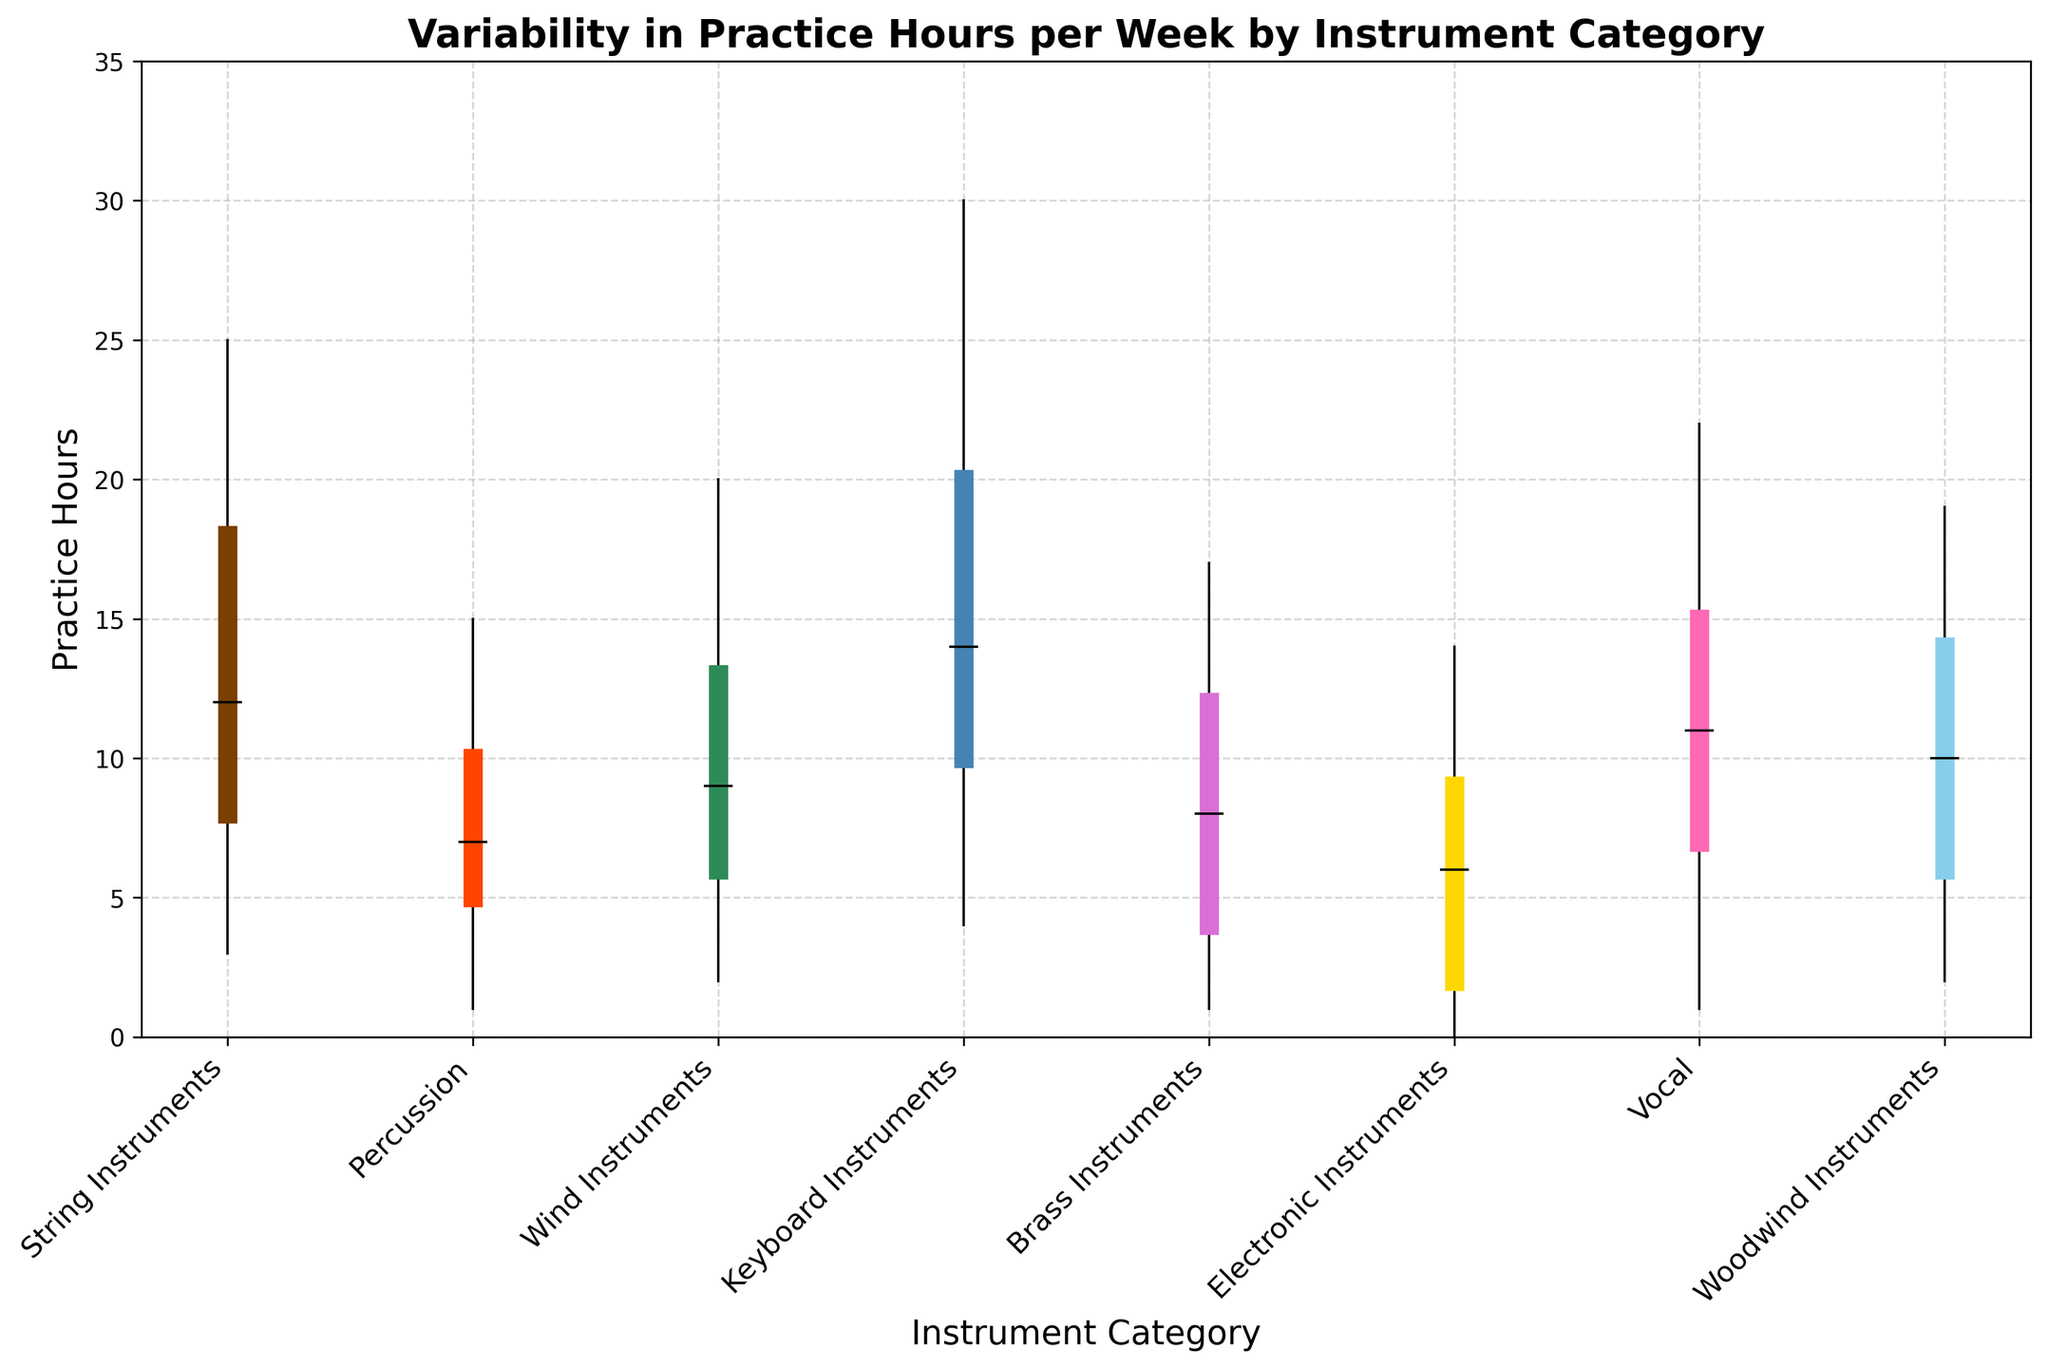Which instrument category has the highest median practice hours? The highest median practice hours can be found by comparing the median values for each instrument category. Keyboard Instruments have a median of 14 hours, which is the highest.
Answer: Keyboard Instruments Which instrument category has the lowest minimum practice hours? The lowest minimum practice hours can be determined by comparing the minimum values for each instrument category. Electronic Instruments have a minimum of 0 hours, which is the lowest.
Answer: Electronic Instruments How many more practice hours do the third quartile for String Instruments have compared to the median of Wind Instruments? The third quartile for String Instruments is 18 hours, and the median for Wind Instruments is 9 hours. The difference is 18 - 9.
Answer: 9 hours Which two instrument categories have the closest third quartile values? The closest third quartile values can be found by comparing the third quartile values of all the categories. Percussion and Brass Instruments both have a third quartile value of 12.
Answer: Percussion and Brass Instruments What is the range of practice hours for Vocal instruments? The range is found by subtracting the minimum value from the maximum value for Vocal instruments. The maximum is 22 hours, and the minimum is 1 hour. The range is 22 - 1.
Answer: 21 hours Which instrument category shows the most variability in practice hours? The most variability can be identified by looking at the maximum range between minimum and maximum values. Keyboard Instruments have a range of 30 - 4 = 26 hours, which is the largest.
Answer: Keyboard Instruments What is the average of the medians for Percussion and Electronic Instruments? To find the average, add the medians of Percussion (7 hours) and Electronic Instruments (6 hours) and then divide by 2. (7 + 6) / 2 = 6.5.
Answer: 6.5 hours Which instrument categories have their median practice hours greater than 10 hours? Compare the median practice hours with 10 hours. String Instruments, Keyboard Instruments, Vocal, and Woodwind Instruments all have median practice hours greater than 10.
Answer: String Instruments, Keyboard Instruments, Vocal, and Woodwind Instruments How does the median practice hours of Wind Instruments compare to the first quartile of Brass Instruments? The median of Wind Instruments is 9 hours, while the first quartile of Brass Instruments is 4 hours. 9 is greater than 4.
Answer: Greater Which instrument category has the smallest difference between its first and third quartile? The difference can be found by subtracting the first quartile from the third quartile for each category. Percussion has a first quartile of 5 and a third quartile of 10, making the difference 5, which is the smallest.
Answer: Percussion 